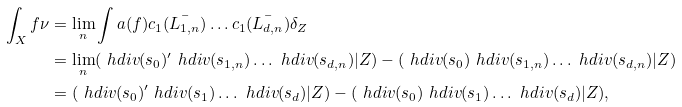Convert formula to latex. <formula><loc_0><loc_0><loc_500><loc_500>\int _ { X } f \nu & = \lim _ { n } \int a ( f ) c _ { 1 } ( \bar { L _ { 1 , n } } ) \dots c _ { 1 } ( \bar { L _ { d , n } } ) \delta _ { Z } \\ & = \lim _ { n } ( \ h d i v ( s _ { 0 } ) ^ { \prime } \ h d i v ( s _ { 1 , n } ) \dots \ h d i v ( s _ { d , n } ) | Z ) - ( \ h d i v ( s _ { 0 } ) \ h d i v ( s _ { 1 , n } ) \dots \ h d i v ( s _ { d , n } ) | Z ) \\ & = ( \ h d i v ( s _ { 0 } ) ^ { \prime } \ h d i v ( s _ { 1 } ) \dots \ h d i v ( s _ { d } ) | Z ) - ( \ h d i v ( s _ { 0 } ) \ h d i v ( s _ { 1 } ) \dots \ h d i v ( s _ { d } ) | Z ) ,</formula> 